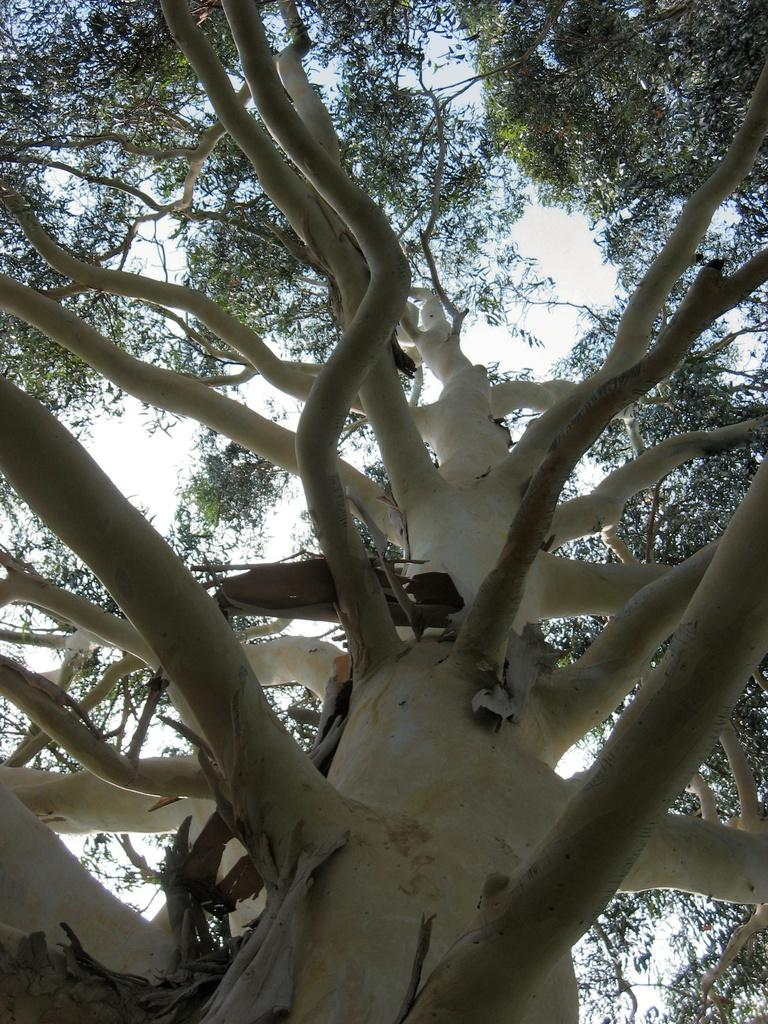What type of plant can be seen in the image? There is a tree in the image. What part of the natural environment is visible in the image? The sky is visible in the image. What type of cave can be seen in the image? There is no cave present in the image; it features a tree and the sky. 